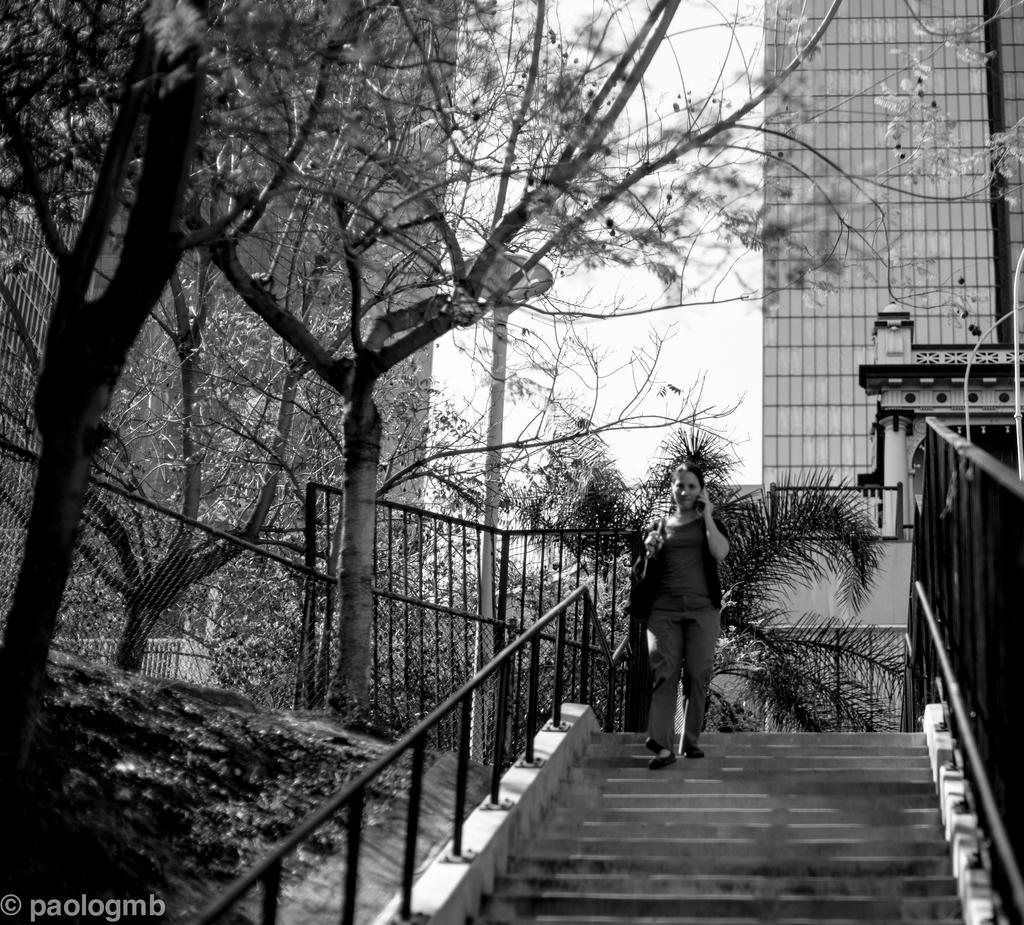How would you summarize this image in a sentence or two? In the image we can see there is a person standing on the stairs. Behind there are trees and buildings. The image is in black and white colour. 